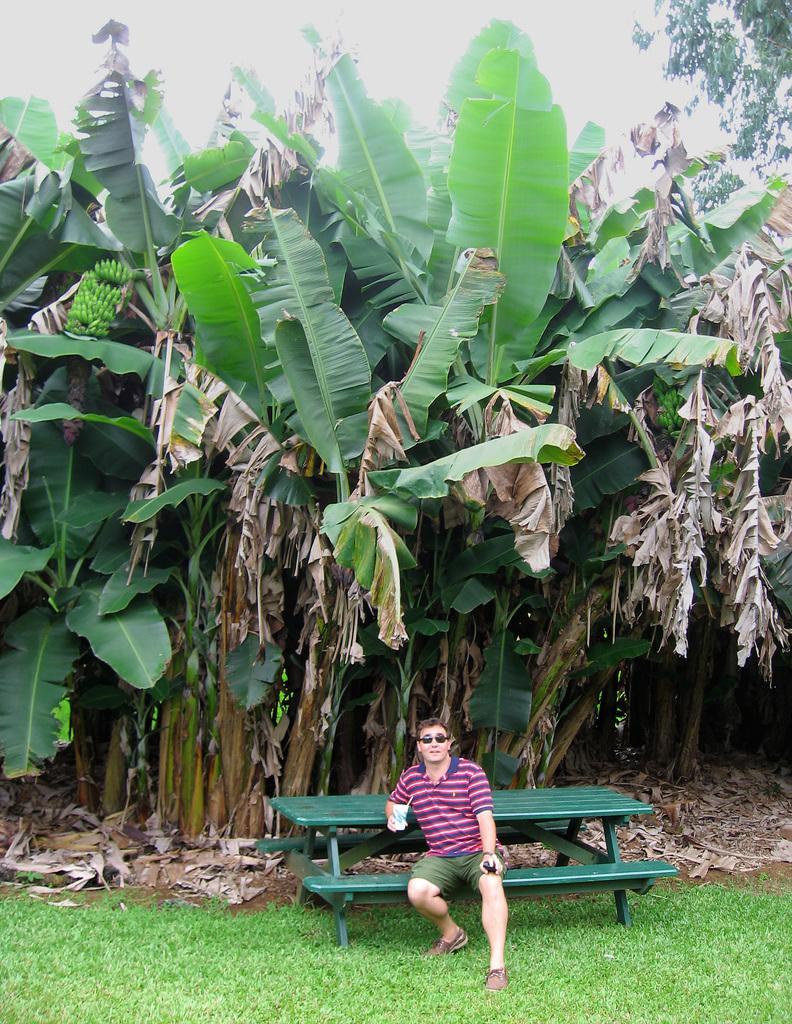How would you summarize this image in a sentence or two? In this image I can see a man is sitting on a bench. I can also see he is holding a glass and wearing specs. In the background I can see number of trees. 